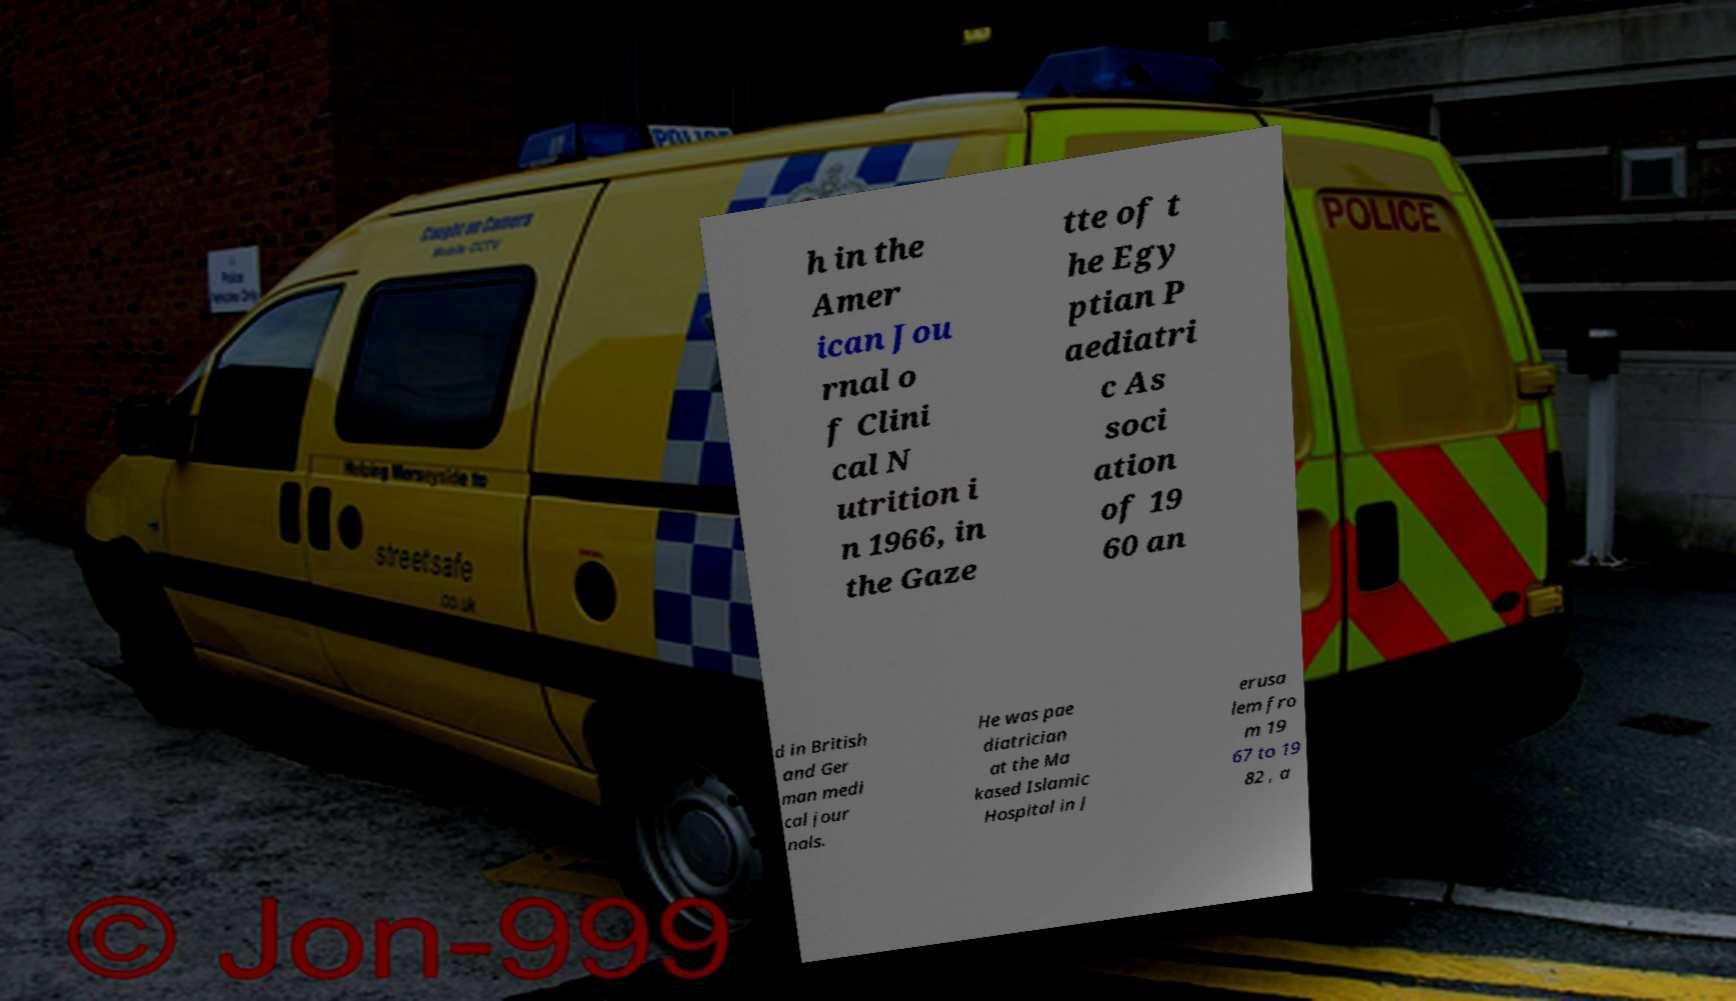Please identify and transcribe the text found in this image. h in the Amer ican Jou rnal o f Clini cal N utrition i n 1966, in the Gaze tte of t he Egy ptian P aediatri c As soci ation of 19 60 an d in British and Ger man medi cal jour nals. He was pae diatrician at the Ma kased Islamic Hospital in J erusa lem fro m 19 67 to 19 82 , a 